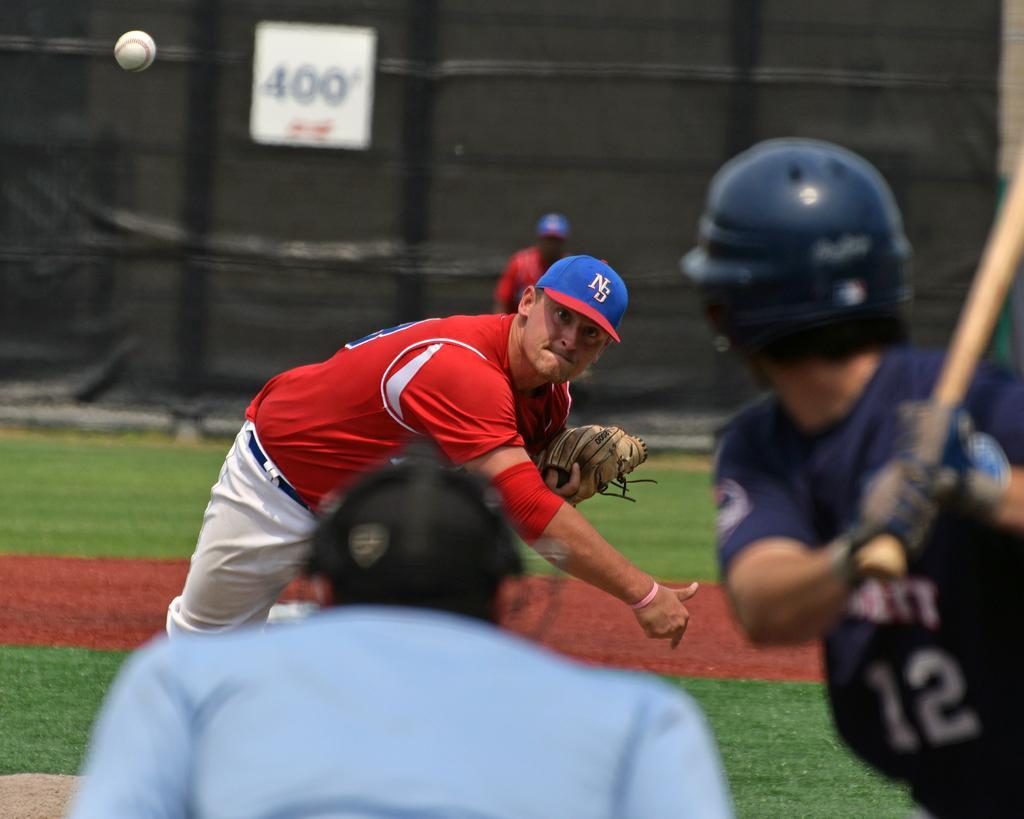Could you give a brief overview of what you see in this image? Here we can see three persons on the ground. One person is holding a bat and another person is throwing a ball. There is a blur background and we can see a person and a board. 